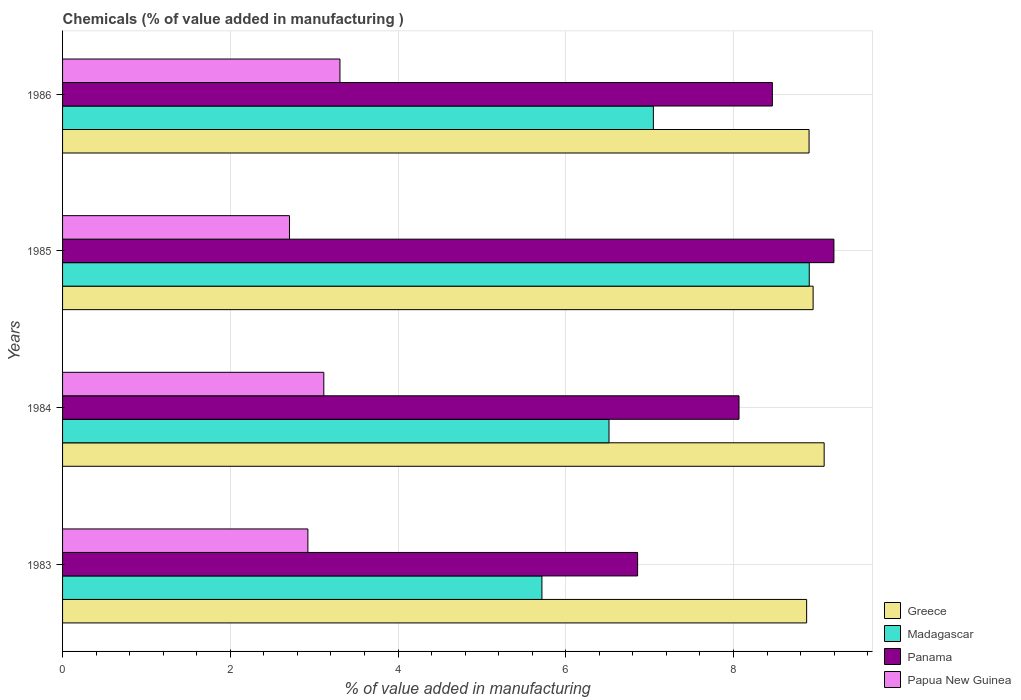How many different coloured bars are there?
Your answer should be very brief. 4. How many groups of bars are there?
Your response must be concise. 4. How many bars are there on the 3rd tick from the top?
Keep it short and to the point. 4. How many bars are there on the 2nd tick from the bottom?
Your response must be concise. 4. What is the label of the 4th group of bars from the top?
Make the answer very short. 1983. In how many cases, is the number of bars for a given year not equal to the number of legend labels?
Provide a short and direct response. 0. What is the value added in manufacturing chemicals in Panama in 1984?
Keep it short and to the point. 8.07. Across all years, what is the maximum value added in manufacturing chemicals in Papua New Guinea?
Your answer should be compact. 3.31. Across all years, what is the minimum value added in manufacturing chemicals in Greece?
Make the answer very short. 8.87. In which year was the value added in manufacturing chemicals in Papua New Guinea maximum?
Your response must be concise. 1986. In which year was the value added in manufacturing chemicals in Panama minimum?
Keep it short and to the point. 1983. What is the total value added in manufacturing chemicals in Papua New Guinea in the graph?
Provide a succinct answer. 12.05. What is the difference between the value added in manufacturing chemicals in Papua New Guinea in 1983 and that in 1986?
Keep it short and to the point. -0.38. What is the difference between the value added in manufacturing chemicals in Madagascar in 1984 and the value added in manufacturing chemicals in Greece in 1986?
Ensure brevity in your answer.  -2.39. What is the average value added in manufacturing chemicals in Madagascar per year?
Offer a very short reply. 7.05. In the year 1984, what is the difference between the value added in manufacturing chemicals in Greece and value added in manufacturing chemicals in Panama?
Provide a succinct answer. 1.02. What is the ratio of the value added in manufacturing chemicals in Papua New Guinea in 1984 to that in 1986?
Offer a terse response. 0.94. Is the difference between the value added in manufacturing chemicals in Greece in 1984 and 1986 greater than the difference between the value added in manufacturing chemicals in Panama in 1984 and 1986?
Your response must be concise. Yes. What is the difference between the highest and the second highest value added in manufacturing chemicals in Panama?
Keep it short and to the point. 0.73. What is the difference between the highest and the lowest value added in manufacturing chemicals in Panama?
Provide a succinct answer. 2.34. In how many years, is the value added in manufacturing chemicals in Greece greater than the average value added in manufacturing chemicals in Greece taken over all years?
Keep it short and to the point. 1. Is the sum of the value added in manufacturing chemicals in Papua New Guinea in 1983 and 1986 greater than the maximum value added in manufacturing chemicals in Madagascar across all years?
Make the answer very short. No. What does the 2nd bar from the top in 1983 represents?
Offer a very short reply. Panama. What does the 3rd bar from the bottom in 1985 represents?
Make the answer very short. Panama. Are all the bars in the graph horizontal?
Your response must be concise. Yes. What is the difference between two consecutive major ticks on the X-axis?
Make the answer very short. 2. Are the values on the major ticks of X-axis written in scientific E-notation?
Make the answer very short. No. What is the title of the graph?
Your answer should be compact. Chemicals (% of value added in manufacturing ). What is the label or title of the X-axis?
Offer a very short reply. % of value added in manufacturing. What is the % of value added in manufacturing in Greece in 1983?
Provide a succinct answer. 8.87. What is the % of value added in manufacturing of Madagascar in 1983?
Offer a terse response. 5.72. What is the % of value added in manufacturing of Panama in 1983?
Keep it short and to the point. 6.86. What is the % of value added in manufacturing in Papua New Guinea in 1983?
Keep it short and to the point. 2.93. What is the % of value added in manufacturing of Greece in 1984?
Offer a terse response. 9.08. What is the % of value added in manufacturing of Madagascar in 1984?
Offer a terse response. 6.52. What is the % of value added in manufacturing of Panama in 1984?
Provide a succinct answer. 8.07. What is the % of value added in manufacturing of Papua New Guinea in 1984?
Your answer should be very brief. 3.12. What is the % of value added in manufacturing in Greece in 1985?
Offer a terse response. 8.95. What is the % of value added in manufacturing in Madagascar in 1985?
Your answer should be compact. 8.9. What is the % of value added in manufacturing of Panama in 1985?
Provide a succinct answer. 9.2. What is the % of value added in manufacturing in Papua New Guinea in 1985?
Your response must be concise. 2.71. What is the % of value added in manufacturing in Greece in 1986?
Your answer should be very brief. 8.9. What is the % of value added in manufacturing of Madagascar in 1986?
Offer a terse response. 7.04. What is the % of value added in manufacturing in Panama in 1986?
Give a very brief answer. 8.46. What is the % of value added in manufacturing of Papua New Guinea in 1986?
Ensure brevity in your answer.  3.31. Across all years, what is the maximum % of value added in manufacturing of Greece?
Provide a short and direct response. 9.08. Across all years, what is the maximum % of value added in manufacturing in Madagascar?
Provide a succinct answer. 8.9. Across all years, what is the maximum % of value added in manufacturing in Panama?
Ensure brevity in your answer.  9.2. Across all years, what is the maximum % of value added in manufacturing of Papua New Guinea?
Give a very brief answer. 3.31. Across all years, what is the minimum % of value added in manufacturing of Greece?
Give a very brief answer. 8.87. Across all years, what is the minimum % of value added in manufacturing of Madagascar?
Provide a succinct answer. 5.72. Across all years, what is the minimum % of value added in manufacturing of Panama?
Your answer should be compact. 6.86. Across all years, what is the minimum % of value added in manufacturing in Papua New Guinea?
Offer a terse response. 2.71. What is the total % of value added in manufacturing of Greece in the graph?
Ensure brevity in your answer.  35.8. What is the total % of value added in manufacturing of Madagascar in the graph?
Give a very brief answer. 28.18. What is the total % of value added in manufacturing in Panama in the graph?
Your response must be concise. 32.58. What is the total % of value added in manufacturing of Papua New Guinea in the graph?
Ensure brevity in your answer.  12.05. What is the difference between the % of value added in manufacturing in Greece in 1983 and that in 1984?
Your response must be concise. -0.21. What is the difference between the % of value added in manufacturing in Madagascar in 1983 and that in 1984?
Provide a succinct answer. -0.8. What is the difference between the % of value added in manufacturing of Panama in 1983 and that in 1984?
Provide a succinct answer. -1.21. What is the difference between the % of value added in manufacturing in Papua New Guinea in 1983 and that in 1984?
Provide a short and direct response. -0.19. What is the difference between the % of value added in manufacturing of Greece in 1983 and that in 1985?
Provide a short and direct response. -0.08. What is the difference between the % of value added in manufacturing of Madagascar in 1983 and that in 1985?
Give a very brief answer. -3.19. What is the difference between the % of value added in manufacturing of Panama in 1983 and that in 1985?
Provide a succinct answer. -2.34. What is the difference between the % of value added in manufacturing of Papua New Guinea in 1983 and that in 1985?
Provide a short and direct response. 0.22. What is the difference between the % of value added in manufacturing in Greece in 1983 and that in 1986?
Keep it short and to the point. -0.03. What is the difference between the % of value added in manufacturing in Madagascar in 1983 and that in 1986?
Your answer should be very brief. -1.33. What is the difference between the % of value added in manufacturing of Panama in 1983 and that in 1986?
Your answer should be very brief. -1.61. What is the difference between the % of value added in manufacturing of Papua New Guinea in 1983 and that in 1986?
Keep it short and to the point. -0.38. What is the difference between the % of value added in manufacturing of Greece in 1984 and that in 1985?
Your response must be concise. 0.13. What is the difference between the % of value added in manufacturing in Madagascar in 1984 and that in 1985?
Give a very brief answer. -2.39. What is the difference between the % of value added in manufacturing in Panama in 1984 and that in 1985?
Provide a short and direct response. -1.13. What is the difference between the % of value added in manufacturing in Papua New Guinea in 1984 and that in 1985?
Your response must be concise. 0.41. What is the difference between the % of value added in manufacturing of Greece in 1984 and that in 1986?
Ensure brevity in your answer.  0.18. What is the difference between the % of value added in manufacturing of Madagascar in 1984 and that in 1986?
Give a very brief answer. -0.53. What is the difference between the % of value added in manufacturing in Panama in 1984 and that in 1986?
Offer a very short reply. -0.4. What is the difference between the % of value added in manufacturing in Papua New Guinea in 1984 and that in 1986?
Give a very brief answer. -0.19. What is the difference between the % of value added in manufacturing in Greece in 1985 and that in 1986?
Your answer should be compact. 0.05. What is the difference between the % of value added in manufacturing of Madagascar in 1985 and that in 1986?
Your answer should be very brief. 1.86. What is the difference between the % of value added in manufacturing in Panama in 1985 and that in 1986?
Your answer should be very brief. 0.73. What is the difference between the % of value added in manufacturing in Papua New Guinea in 1985 and that in 1986?
Provide a succinct answer. -0.6. What is the difference between the % of value added in manufacturing in Greece in 1983 and the % of value added in manufacturing in Madagascar in 1984?
Your answer should be compact. 2.36. What is the difference between the % of value added in manufacturing of Greece in 1983 and the % of value added in manufacturing of Panama in 1984?
Provide a short and direct response. 0.81. What is the difference between the % of value added in manufacturing of Greece in 1983 and the % of value added in manufacturing of Papua New Guinea in 1984?
Your answer should be very brief. 5.76. What is the difference between the % of value added in manufacturing in Madagascar in 1983 and the % of value added in manufacturing in Panama in 1984?
Your response must be concise. -2.35. What is the difference between the % of value added in manufacturing of Madagascar in 1983 and the % of value added in manufacturing of Papua New Guinea in 1984?
Your answer should be very brief. 2.6. What is the difference between the % of value added in manufacturing in Panama in 1983 and the % of value added in manufacturing in Papua New Guinea in 1984?
Offer a very short reply. 3.74. What is the difference between the % of value added in manufacturing of Greece in 1983 and the % of value added in manufacturing of Madagascar in 1985?
Provide a succinct answer. -0.03. What is the difference between the % of value added in manufacturing in Greece in 1983 and the % of value added in manufacturing in Panama in 1985?
Provide a succinct answer. -0.33. What is the difference between the % of value added in manufacturing in Greece in 1983 and the % of value added in manufacturing in Papua New Guinea in 1985?
Your answer should be compact. 6.17. What is the difference between the % of value added in manufacturing of Madagascar in 1983 and the % of value added in manufacturing of Panama in 1985?
Give a very brief answer. -3.48. What is the difference between the % of value added in manufacturing of Madagascar in 1983 and the % of value added in manufacturing of Papua New Guinea in 1985?
Offer a terse response. 3.01. What is the difference between the % of value added in manufacturing in Panama in 1983 and the % of value added in manufacturing in Papua New Guinea in 1985?
Offer a terse response. 4.15. What is the difference between the % of value added in manufacturing in Greece in 1983 and the % of value added in manufacturing in Madagascar in 1986?
Your answer should be very brief. 1.83. What is the difference between the % of value added in manufacturing in Greece in 1983 and the % of value added in manufacturing in Panama in 1986?
Provide a short and direct response. 0.41. What is the difference between the % of value added in manufacturing in Greece in 1983 and the % of value added in manufacturing in Papua New Guinea in 1986?
Offer a terse response. 5.56. What is the difference between the % of value added in manufacturing in Madagascar in 1983 and the % of value added in manufacturing in Panama in 1986?
Offer a terse response. -2.75. What is the difference between the % of value added in manufacturing in Madagascar in 1983 and the % of value added in manufacturing in Papua New Guinea in 1986?
Offer a terse response. 2.41. What is the difference between the % of value added in manufacturing in Panama in 1983 and the % of value added in manufacturing in Papua New Guinea in 1986?
Provide a succinct answer. 3.55. What is the difference between the % of value added in manufacturing of Greece in 1984 and the % of value added in manufacturing of Madagascar in 1985?
Provide a short and direct response. 0.18. What is the difference between the % of value added in manufacturing of Greece in 1984 and the % of value added in manufacturing of Panama in 1985?
Your answer should be compact. -0.12. What is the difference between the % of value added in manufacturing of Greece in 1984 and the % of value added in manufacturing of Papua New Guinea in 1985?
Make the answer very short. 6.38. What is the difference between the % of value added in manufacturing in Madagascar in 1984 and the % of value added in manufacturing in Panama in 1985?
Offer a very short reply. -2.68. What is the difference between the % of value added in manufacturing of Madagascar in 1984 and the % of value added in manufacturing of Papua New Guinea in 1985?
Offer a very short reply. 3.81. What is the difference between the % of value added in manufacturing of Panama in 1984 and the % of value added in manufacturing of Papua New Guinea in 1985?
Provide a short and direct response. 5.36. What is the difference between the % of value added in manufacturing in Greece in 1984 and the % of value added in manufacturing in Madagascar in 1986?
Offer a very short reply. 2.04. What is the difference between the % of value added in manufacturing in Greece in 1984 and the % of value added in manufacturing in Panama in 1986?
Your response must be concise. 0.62. What is the difference between the % of value added in manufacturing of Greece in 1984 and the % of value added in manufacturing of Papua New Guinea in 1986?
Give a very brief answer. 5.77. What is the difference between the % of value added in manufacturing in Madagascar in 1984 and the % of value added in manufacturing in Panama in 1986?
Keep it short and to the point. -1.95. What is the difference between the % of value added in manufacturing in Madagascar in 1984 and the % of value added in manufacturing in Papua New Guinea in 1986?
Keep it short and to the point. 3.21. What is the difference between the % of value added in manufacturing in Panama in 1984 and the % of value added in manufacturing in Papua New Guinea in 1986?
Provide a succinct answer. 4.76. What is the difference between the % of value added in manufacturing of Greece in 1985 and the % of value added in manufacturing of Madagascar in 1986?
Keep it short and to the point. 1.9. What is the difference between the % of value added in manufacturing in Greece in 1985 and the % of value added in manufacturing in Panama in 1986?
Ensure brevity in your answer.  0.49. What is the difference between the % of value added in manufacturing of Greece in 1985 and the % of value added in manufacturing of Papua New Guinea in 1986?
Keep it short and to the point. 5.64. What is the difference between the % of value added in manufacturing of Madagascar in 1985 and the % of value added in manufacturing of Panama in 1986?
Your answer should be very brief. 0.44. What is the difference between the % of value added in manufacturing in Madagascar in 1985 and the % of value added in manufacturing in Papua New Guinea in 1986?
Offer a very short reply. 5.6. What is the difference between the % of value added in manufacturing of Panama in 1985 and the % of value added in manufacturing of Papua New Guinea in 1986?
Your response must be concise. 5.89. What is the average % of value added in manufacturing in Greece per year?
Make the answer very short. 8.95. What is the average % of value added in manufacturing of Madagascar per year?
Provide a short and direct response. 7.05. What is the average % of value added in manufacturing in Panama per year?
Make the answer very short. 8.15. What is the average % of value added in manufacturing in Papua New Guinea per year?
Make the answer very short. 3.01. In the year 1983, what is the difference between the % of value added in manufacturing in Greece and % of value added in manufacturing in Madagascar?
Your response must be concise. 3.16. In the year 1983, what is the difference between the % of value added in manufacturing of Greece and % of value added in manufacturing of Panama?
Provide a succinct answer. 2.02. In the year 1983, what is the difference between the % of value added in manufacturing in Greece and % of value added in manufacturing in Papua New Guinea?
Ensure brevity in your answer.  5.95. In the year 1983, what is the difference between the % of value added in manufacturing of Madagascar and % of value added in manufacturing of Panama?
Provide a short and direct response. -1.14. In the year 1983, what is the difference between the % of value added in manufacturing of Madagascar and % of value added in manufacturing of Papua New Guinea?
Ensure brevity in your answer.  2.79. In the year 1983, what is the difference between the % of value added in manufacturing in Panama and % of value added in manufacturing in Papua New Guinea?
Ensure brevity in your answer.  3.93. In the year 1984, what is the difference between the % of value added in manufacturing in Greece and % of value added in manufacturing in Madagascar?
Offer a terse response. 2.57. In the year 1984, what is the difference between the % of value added in manufacturing in Greece and % of value added in manufacturing in Panama?
Keep it short and to the point. 1.02. In the year 1984, what is the difference between the % of value added in manufacturing in Greece and % of value added in manufacturing in Papua New Guinea?
Provide a succinct answer. 5.97. In the year 1984, what is the difference between the % of value added in manufacturing in Madagascar and % of value added in manufacturing in Panama?
Offer a terse response. -1.55. In the year 1984, what is the difference between the % of value added in manufacturing of Madagascar and % of value added in manufacturing of Papua New Guinea?
Your answer should be compact. 3.4. In the year 1984, what is the difference between the % of value added in manufacturing of Panama and % of value added in manufacturing of Papua New Guinea?
Keep it short and to the point. 4.95. In the year 1985, what is the difference between the % of value added in manufacturing of Greece and % of value added in manufacturing of Madagascar?
Offer a very short reply. 0.05. In the year 1985, what is the difference between the % of value added in manufacturing of Greece and % of value added in manufacturing of Panama?
Keep it short and to the point. -0.25. In the year 1985, what is the difference between the % of value added in manufacturing in Greece and % of value added in manufacturing in Papua New Guinea?
Offer a terse response. 6.24. In the year 1985, what is the difference between the % of value added in manufacturing in Madagascar and % of value added in manufacturing in Panama?
Your response must be concise. -0.29. In the year 1985, what is the difference between the % of value added in manufacturing of Madagascar and % of value added in manufacturing of Papua New Guinea?
Make the answer very short. 6.2. In the year 1985, what is the difference between the % of value added in manufacturing of Panama and % of value added in manufacturing of Papua New Guinea?
Give a very brief answer. 6.49. In the year 1986, what is the difference between the % of value added in manufacturing of Greece and % of value added in manufacturing of Madagascar?
Keep it short and to the point. 1.86. In the year 1986, what is the difference between the % of value added in manufacturing in Greece and % of value added in manufacturing in Panama?
Your response must be concise. 0.44. In the year 1986, what is the difference between the % of value added in manufacturing in Greece and % of value added in manufacturing in Papua New Guinea?
Ensure brevity in your answer.  5.59. In the year 1986, what is the difference between the % of value added in manufacturing in Madagascar and % of value added in manufacturing in Panama?
Make the answer very short. -1.42. In the year 1986, what is the difference between the % of value added in manufacturing of Madagascar and % of value added in manufacturing of Papua New Guinea?
Make the answer very short. 3.74. In the year 1986, what is the difference between the % of value added in manufacturing in Panama and % of value added in manufacturing in Papua New Guinea?
Provide a short and direct response. 5.16. What is the ratio of the % of value added in manufacturing of Greece in 1983 to that in 1984?
Your answer should be compact. 0.98. What is the ratio of the % of value added in manufacturing in Madagascar in 1983 to that in 1984?
Ensure brevity in your answer.  0.88. What is the ratio of the % of value added in manufacturing of Panama in 1983 to that in 1984?
Provide a short and direct response. 0.85. What is the ratio of the % of value added in manufacturing of Papua New Guinea in 1983 to that in 1984?
Provide a short and direct response. 0.94. What is the ratio of the % of value added in manufacturing in Madagascar in 1983 to that in 1985?
Ensure brevity in your answer.  0.64. What is the ratio of the % of value added in manufacturing in Panama in 1983 to that in 1985?
Give a very brief answer. 0.75. What is the ratio of the % of value added in manufacturing of Papua New Guinea in 1983 to that in 1985?
Offer a very short reply. 1.08. What is the ratio of the % of value added in manufacturing in Greece in 1983 to that in 1986?
Offer a very short reply. 1. What is the ratio of the % of value added in manufacturing of Madagascar in 1983 to that in 1986?
Provide a succinct answer. 0.81. What is the ratio of the % of value added in manufacturing in Panama in 1983 to that in 1986?
Your answer should be very brief. 0.81. What is the ratio of the % of value added in manufacturing in Papua New Guinea in 1983 to that in 1986?
Provide a short and direct response. 0.88. What is the ratio of the % of value added in manufacturing of Greece in 1984 to that in 1985?
Offer a terse response. 1.01. What is the ratio of the % of value added in manufacturing of Madagascar in 1984 to that in 1985?
Your answer should be compact. 0.73. What is the ratio of the % of value added in manufacturing of Panama in 1984 to that in 1985?
Your answer should be very brief. 0.88. What is the ratio of the % of value added in manufacturing in Papua New Guinea in 1984 to that in 1985?
Provide a succinct answer. 1.15. What is the ratio of the % of value added in manufacturing in Greece in 1984 to that in 1986?
Offer a very short reply. 1.02. What is the ratio of the % of value added in manufacturing in Madagascar in 1984 to that in 1986?
Your answer should be very brief. 0.92. What is the ratio of the % of value added in manufacturing of Panama in 1984 to that in 1986?
Offer a very short reply. 0.95. What is the ratio of the % of value added in manufacturing of Papua New Guinea in 1984 to that in 1986?
Make the answer very short. 0.94. What is the ratio of the % of value added in manufacturing of Greece in 1985 to that in 1986?
Your answer should be very brief. 1.01. What is the ratio of the % of value added in manufacturing in Madagascar in 1985 to that in 1986?
Provide a short and direct response. 1.26. What is the ratio of the % of value added in manufacturing in Panama in 1985 to that in 1986?
Give a very brief answer. 1.09. What is the ratio of the % of value added in manufacturing in Papua New Guinea in 1985 to that in 1986?
Ensure brevity in your answer.  0.82. What is the difference between the highest and the second highest % of value added in manufacturing of Greece?
Your response must be concise. 0.13. What is the difference between the highest and the second highest % of value added in manufacturing in Madagascar?
Your answer should be compact. 1.86. What is the difference between the highest and the second highest % of value added in manufacturing in Panama?
Provide a short and direct response. 0.73. What is the difference between the highest and the second highest % of value added in manufacturing in Papua New Guinea?
Your answer should be very brief. 0.19. What is the difference between the highest and the lowest % of value added in manufacturing of Greece?
Your response must be concise. 0.21. What is the difference between the highest and the lowest % of value added in manufacturing of Madagascar?
Ensure brevity in your answer.  3.19. What is the difference between the highest and the lowest % of value added in manufacturing of Panama?
Give a very brief answer. 2.34. What is the difference between the highest and the lowest % of value added in manufacturing in Papua New Guinea?
Make the answer very short. 0.6. 